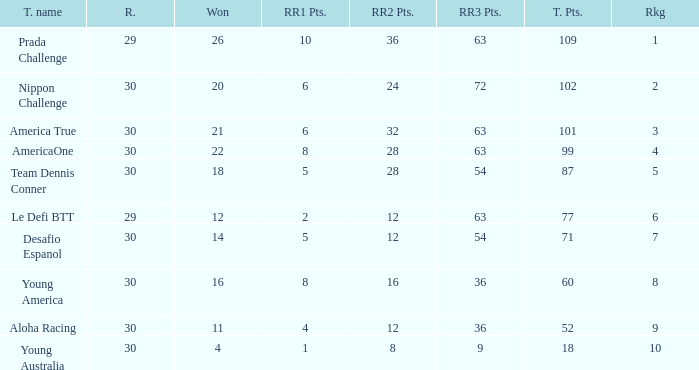Name the ranking for rr2 pts being 8 10.0. 